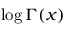Convert formula to latex. <formula><loc_0><loc_0><loc_500><loc_500>\log \Gamma ( x )</formula> 